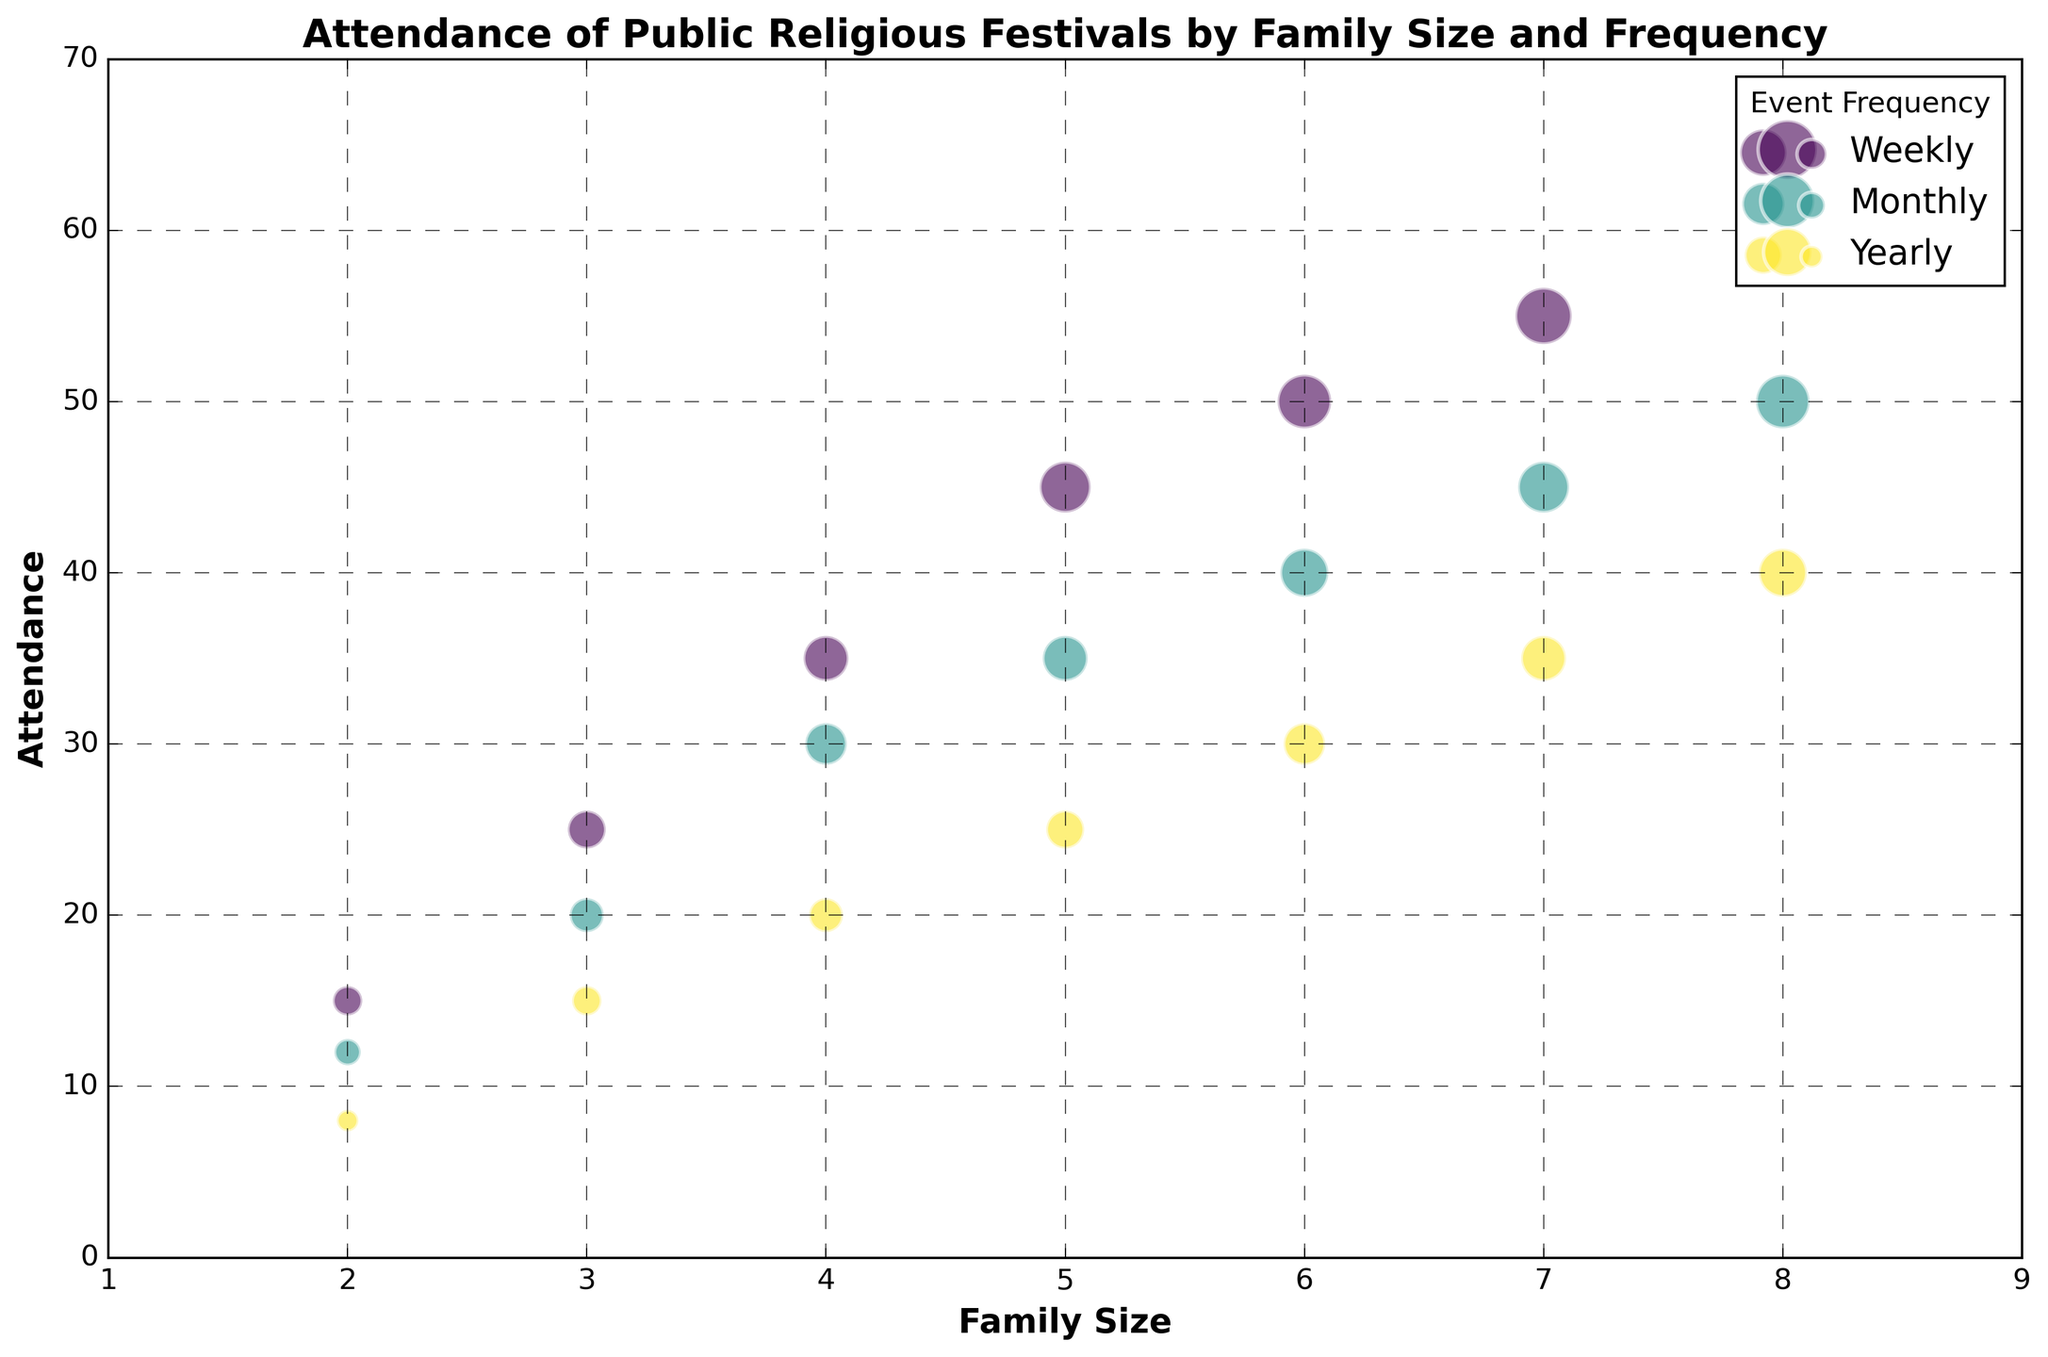What's the trend of attendance as the family size increases? As the family size increases, the attendance for all frequencies (Weekly, Monthly, Yearly) also increases. This can be observed by looking at the bubble sizes along the x-axis from left (small family sizes) to right (large family sizes). The bubbles become larger, indicating higher attendance figures.
Answer: Attendance increases with family size Which event frequency category has the highest attendance for a family size of 5? For a family size of 5, the weekly attendance has the highest attendance. The bubble representing weekly attendance is visually the largest compared to monthly and yearly attendance bubbles within the same family size category.
Answer: Weekly For a family size of 7, by how much does the weekly attendance exceed the yearly attendance? For a family size of 7, the weekly attendance is 55, and the yearly attendance is 35. The difference is calculated as 55 - 35. Hence, the weekly attendance exceeds the yearly attendance by 20.
Answer: 20 Compare the monthly attendance of families with sizes 4 and 6. Which one is higher and by how much? The monthly attendance for a family size of 4 is 30, whereas for a family size of 6, it is 40. The attendance for family size 6 is higher by 40 - 30. Thus, it is higher by 10.
Answer: Family size 6, by 10 What is the average attendance for all family sizes for yearly events? The yearly attendance values are 8, 15, 20, 25, 30, 35, and 40. To find the average: (8 + 15 + 20 + 25 + 30 + 35 + 40) / 7 = 173 / 7 = 24.71. So the average attendance is approximately 24.71.
Answer: 24.71 